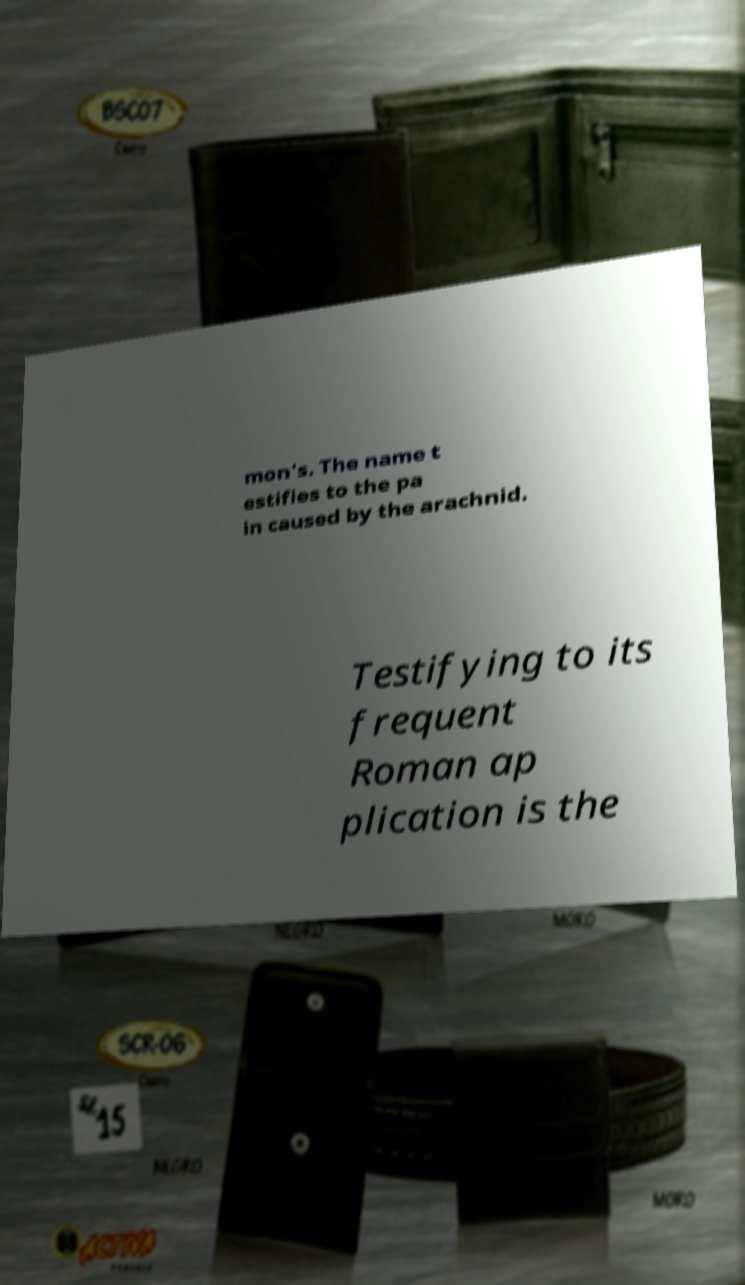For documentation purposes, I need the text within this image transcribed. Could you provide that? mon's. The name t estifies to the pa in caused by the arachnid. Testifying to its frequent Roman ap plication is the 